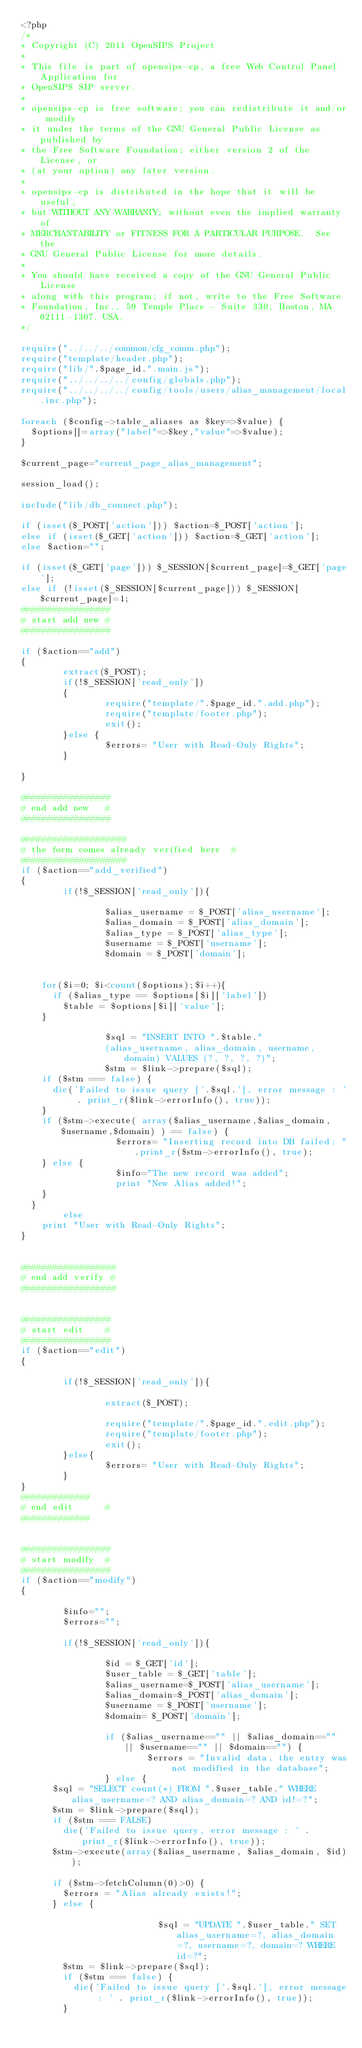<code> <loc_0><loc_0><loc_500><loc_500><_PHP_><?php
/*
* Copyright (C) 2011 OpenSIPS Project
*
* This file is part of opensips-cp, a free Web Control Panel Application for
* OpenSIPS SIP server.
*
* opensips-cp is free software; you can redistribute it and/or modify
* it under the terms of the GNU General Public License as published by
* the Free Software Foundation; either version 2 of the License, or
* (at your option) any later version.
*
* opensips-cp is distributed in the hope that it will be useful,
* but WITHOUT ANY WARRANTY; without even the implied warranty of
* MERCHANTABILITY or FITNESS FOR A PARTICULAR PURPOSE.  See the
* GNU General Public License for more details.
*
* You should have received a copy of the GNU General Public License
* along with this program; if not, write to the Free Software
* Foundation, Inc., 59 Temple Place - Suite 330, Boston, MA  02111-1307, USA.
*/

require("../../../common/cfg_comm.php");
require("template/header.php");
require("lib/".$page_id.".main.js");
require("../../../../config/globals.php");
require("../../../../config/tools/users/alias_management/local.inc.php");

foreach ($config->table_aliases as $key=>$value) {
	$options[]=array("label"=>$key,"value"=>$value);
}

$current_page="current_page_alias_management";

session_load();

include("lib/db_connect.php");

if (isset($_POST['action'])) $action=$_POST['action'];
else if (isset($_GET['action'])) $action=$_GET['action'];
else $action="";

if (isset($_GET['page'])) $_SESSION[$current_page]=$_GET['page'];
else if (!isset($_SESSION[$current_page])) $_SESSION[$current_page]=1;
#################
# start add new #
#################

if ($action=="add")
{
        extract($_POST);
        if(!$_SESSION['read_only'])
        {
                require("template/".$page_id.".add.php");
                require("template/footer.php");
                exit();
        }else {
                $errors= "User with Read-Only Rights";
        }

}

#################
# end add new   #
#################

####################
# the form comes already verified here  #
####################
if ($action=="add_verified")
{
        if(!$_SESSION['read_only']){
				
                $alias_username = $_POST['alias_username'];
                $alias_domain = $_POST['alias_domain'];
                $alias_type = $_POST['alias_type'];
                $username = $_POST['username'];
                $domain = $_POST['domain'];

                
		for($i=0; $i<count($options);$i++){
			if ($alias_type == $options[$i]['label']) 
				$table = $options[$i]['value']; 
		}						

                $sql = "INSERT INTO ".$table."
                (alias_username, alias_domain, username, domain) VALUES (?, ?, ?, ?)";
                $stm = $link->prepare($sql);
		if ($stm === false) {
			die('Failed to issue query ['.$sql.'], error message : ' . print_r($link->errorInfo(), true));
		}
		if ($stm->execute( array($alias_username,$alias_domain,$username,$domain) ) == false) {
                	$errors= "Inserting record into DB failed: ".print_r($stm->errorInfo(), true);
		} else {
	                $info="The new record was added";
        	        print "New Alias added!";
		}
	}
        else
		print "User with Read-Only Rights";
}


##################
# end add verify #
##################


#################
# start edit    #
#################
if ($action=="edit")
{

        if(!$_SESSION['read_only']){

                extract($_POST);

                require("template/".$page_id.".edit.php");
                require("template/footer.php");
                exit();
        }else{
                $errors= "User with Read-Only Rights";
        }
}
#############
# end edit      #
#############


#################
# start modify  #
#################
if ($action=="modify")
{

        $info="";
        $errors="";

        if(!$_SESSION['read_only']){

                $id = $_GET['id'];
                $user_table = $_GET['table'];
                $alias_username=$_POST['alias_username'];
                $alias_domain=$_POST['alias_domain'];
                $username = $_POST['username'];
                $domain= $_POST['domain'];

                if ($alias_username=="" || $alias_domain=="" || $username=="" || $domain=="") {
                        $errors = "Invalid data, the entry was not modified in the database";
                } else {
			$sql = "SELECT count(*) FROM ".$user_table." WHERE alias_username=? AND alias_domain=? AND id!=?";
			$stm = $link->prepare($sql);
			if ($stm === FALSE)
				die('Failed to issue query, error message : ' . print_r($link->errorInfo(), true));
			$stm->execute(array($alias_username, $alias_domain, $id));
			
			if ($stm->fetchColumn(0)>0) {
				$errors = "Alias already exists!";
			} else {

	                        $sql = "UPDATE ".$user_table." SET alias_username=?, alias_domain=?, username=?, domain=? WHERE id=?";
				$stm = $link->prepare($sql);
				if ($stm === false) {
					die('Failed to issue query ['.$sql.'], error message : ' . print_r($link->errorInfo(), true));
				}</code> 